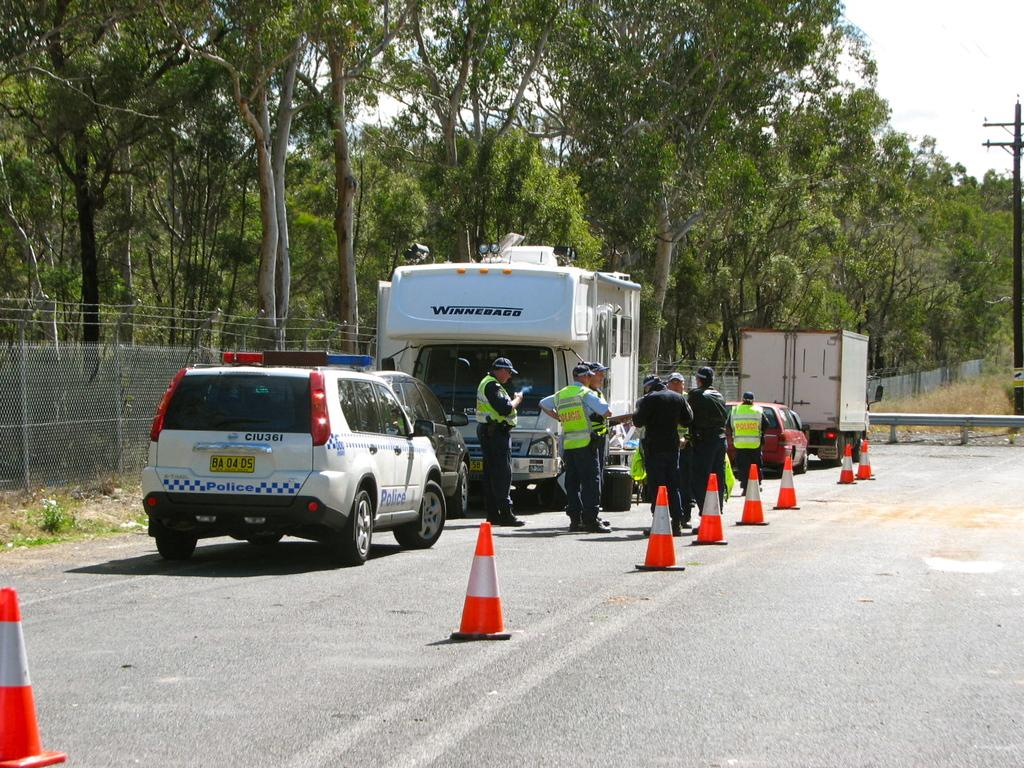What can be seen in the sky in the image? The sky is visible in the image. What type of natural elements are present in the image? There are trees in the image. What man-made object is present in the image? There is a current pole in the image. What is happening on the road in the image? Vehicles are present on the road in the image. Who is visible in the image? People are visible in the image. What safety measures are in place on the road in the image? Traffic cones are on the road in the image. What type of vegetation is present in the image? Dried grass is present in the image. What structures are present in the image to provide boundaries or protection? There is a railing and a fence visible in the image. What type of dinner is being served in the image? There is no dinner present in the image; it features a scene with a sky, trees, current pole, vehicles, people, traffic cones, dried grass, railing, and fence. How many babies are visible in the image? There are no babies present in the image. What show is taking place in the image? There is no show present in the image. 